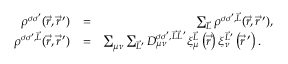Convert formula to latex. <formula><loc_0><loc_0><loc_500><loc_500>\begin{array} { r l r } { \rho ^ { \sigma \sigma ^ { \prime } } ( \vec { r } , \vec { r } \, ^ { \prime } ) } & { = } & { \sum _ { \vec { L } } \rho ^ { \sigma \sigma ^ { \prime } , \vec { L } } ( \vec { r } , \vec { r } \, ^ { \prime } ) , } \\ { \rho ^ { \sigma \sigma ^ { \prime } , \vec { L } } ( \vec { r } , \vec { r } \, ^ { \prime } ) } & { = } & { \sum _ { \mu \nu } \sum _ { \vec { L } ^ { \prime } } D _ { \mu \nu } ^ { \sigma \sigma ^ { \prime } , \vec { L } \vec { L } \, ^ { \prime } } \xi _ { \mu } ^ { \vec { L } } \left ( \vec { r } \right ) \xi _ { \nu } ^ { \vec { L } ^ { \prime } } \left ( \vec { r } \, ^ { \prime } \right ) . \quad } \end{array}</formula> 